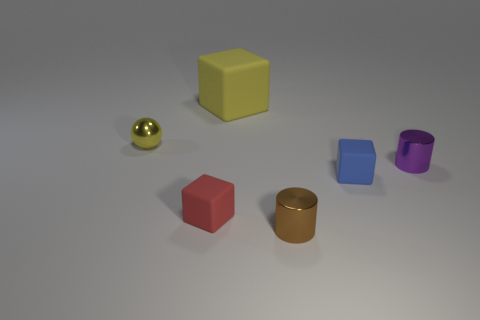What material is the red thing that is the same size as the brown metal cylinder?
Offer a very short reply. Rubber. How many objects are blue rubber cubes or small metal things?
Make the answer very short. 4. How many matte objects are in front of the small purple metal thing and to the left of the blue object?
Make the answer very short. 1. Is the number of large rubber things that are right of the big block less than the number of big cyan rubber balls?
Give a very brief answer. No. There is a purple object that is the same size as the metallic sphere; what shape is it?
Make the answer very short. Cylinder. How many other things are there of the same color as the small sphere?
Make the answer very short. 1. Do the yellow rubber thing and the blue rubber object have the same size?
Your response must be concise. No. What number of things are blue rubber cubes or small rubber things that are to the right of the big yellow thing?
Offer a terse response. 1. Is the number of brown things that are on the right side of the small purple cylinder less than the number of small matte objects that are behind the tiny yellow shiny thing?
Your answer should be very brief. No. What number of other things are made of the same material as the yellow cube?
Keep it short and to the point. 2. 